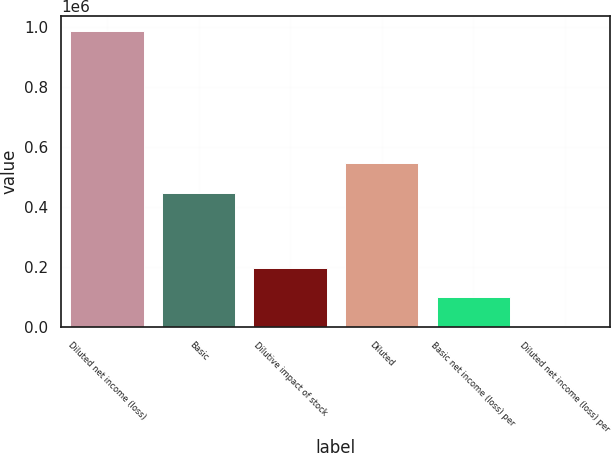<chart> <loc_0><loc_0><loc_500><loc_500><bar_chart><fcel>Diluted net income (loss)<fcel>Basic<fcel>Dilutive impact of stock<fcel>Diluted<fcel>Basic net income (loss) per<fcel>Diluted net income (loss) per<nl><fcel>984729<fcel>445865<fcel>196948<fcel>544338<fcel>98474.9<fcel>2.2<nl></chart> 